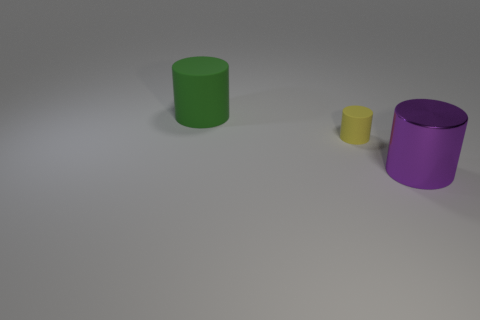Add 1 small purple shiny things. How many objects exist? 4 Subtract all large cyan metal cubes. Subtract all tiny cylinders. How many objects are left? 2 Add 3 big green objects. How many big green objects are left? 4 Add 1 big cyan blocks. How many big cyan blocks exist? 1 Subtract 0 gray balls. How many objects are left? 3 